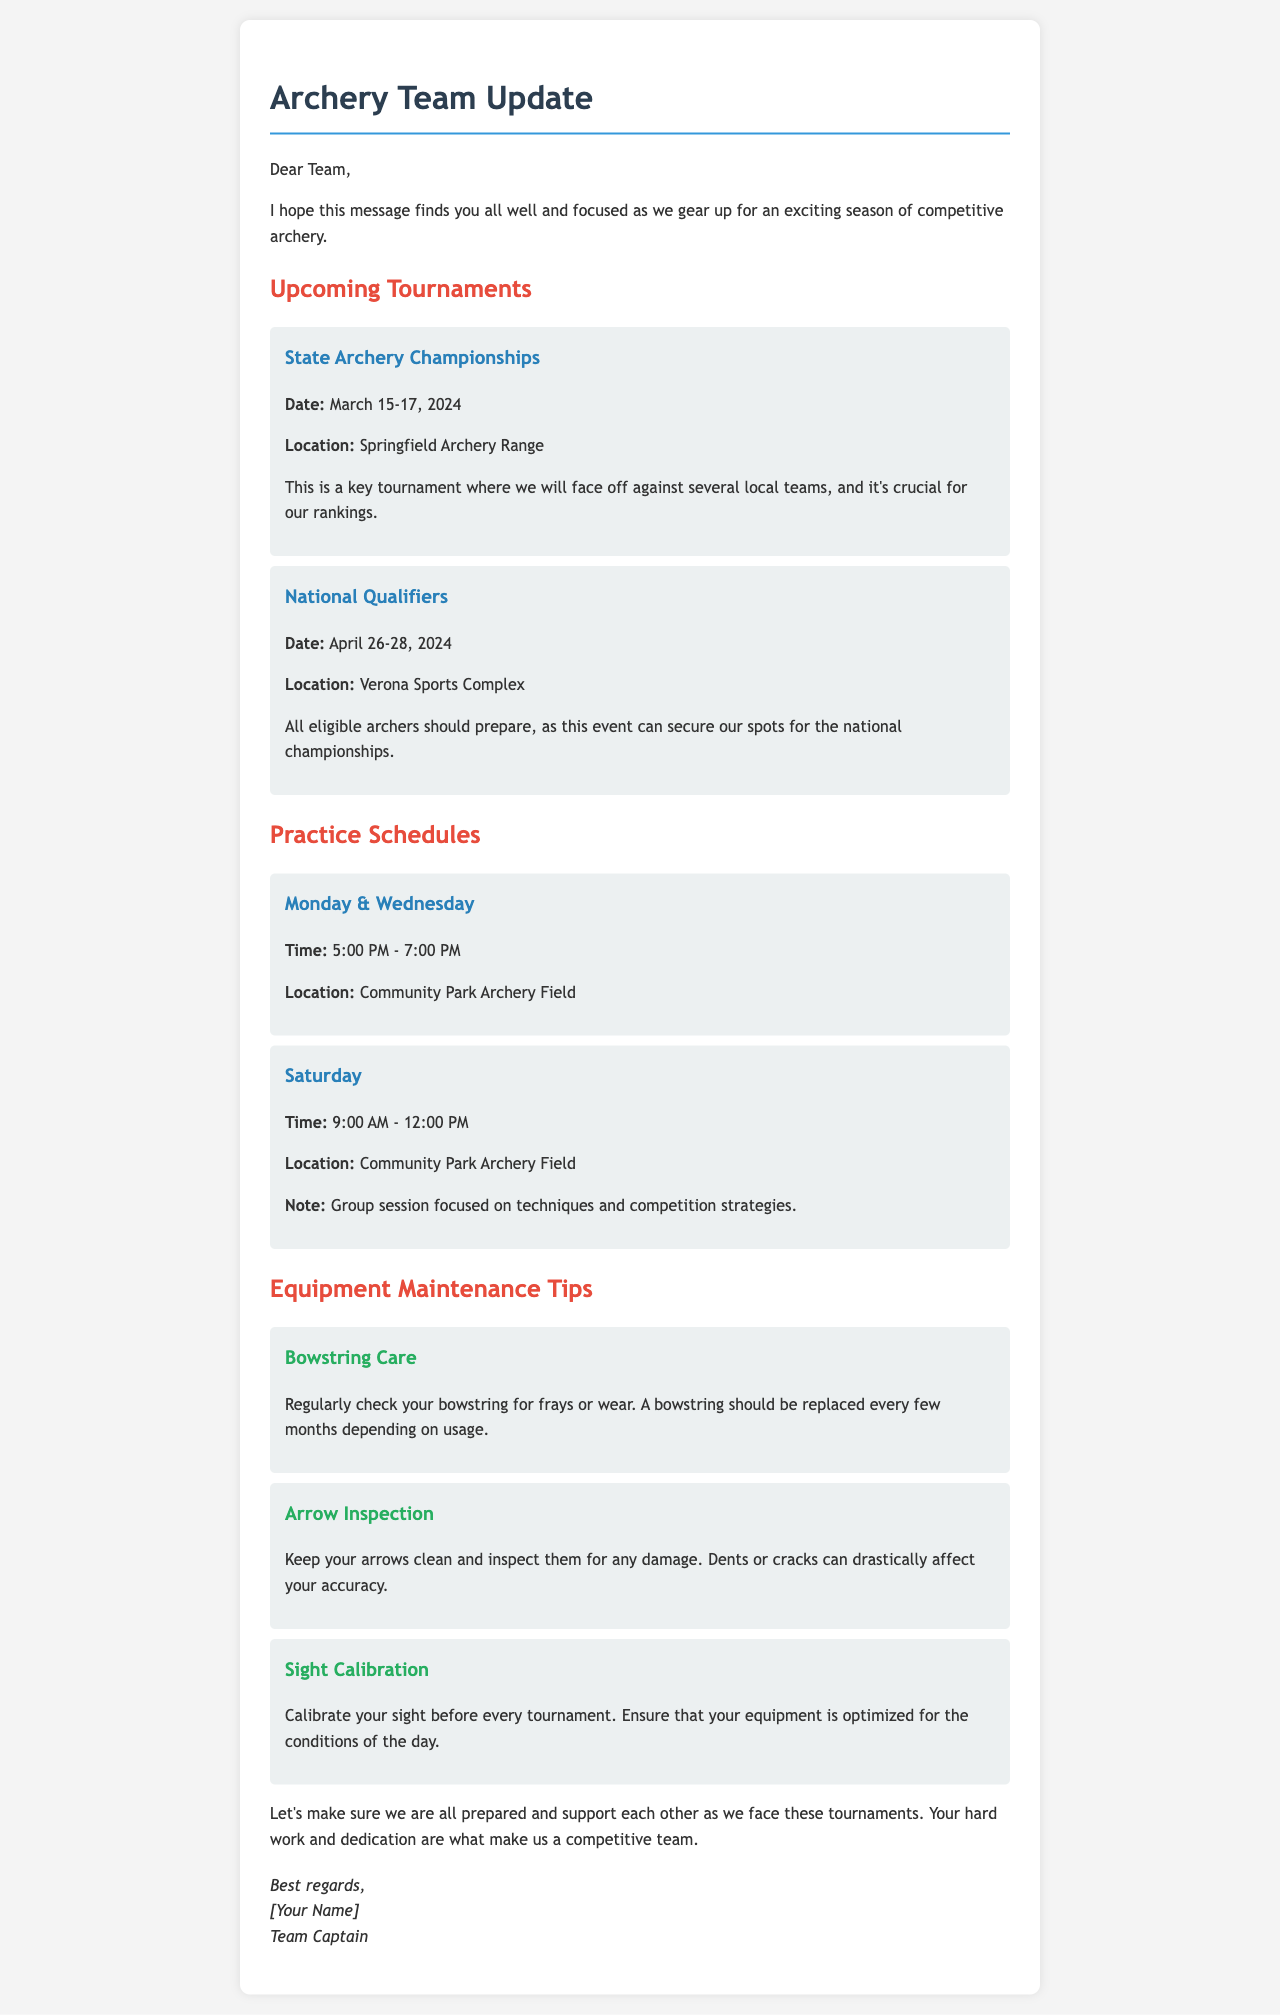What are the dates of the State Archery Championships? The document lists the dates for the State Archery Championships as March 15-17, 2024.
Answer: March 15-17, 2024 Where will the National Qualifiers be held? According to the document, the National Qualifiers will take place at Verona Sports Complex.
Answer: Verona Sports Complex What time do practices occur on weekdays? The document specifies that practice on weekdays is from 5:00 PM to 7:00 PM.
Answer: 5:00 PM - 7:00 PM How often should a bowstring be replaced? The document states that a bowstring should be replaced every few months depending on usage.
Answer: Every few months What key practice is scheduled for Saturday sessions? The document mentions that Saturday sessions are focused on techniques and competition strategies.
Answer: Techniques and competition strategies What is the significance of the State Archery Championships? The document indicates that the State Archery Championships is a key tournament crucial for rankings.
Answer: Crucial for rankings What should archers check regularly for maintenance? The document advises archers to regularly check their bowstring for frays or wear.
Answer: Bowstring Which archery tips address equipment inspection? The document discusses inspecting arrows for any damage and keeping them clean.
Answer: Arrow Inspection 